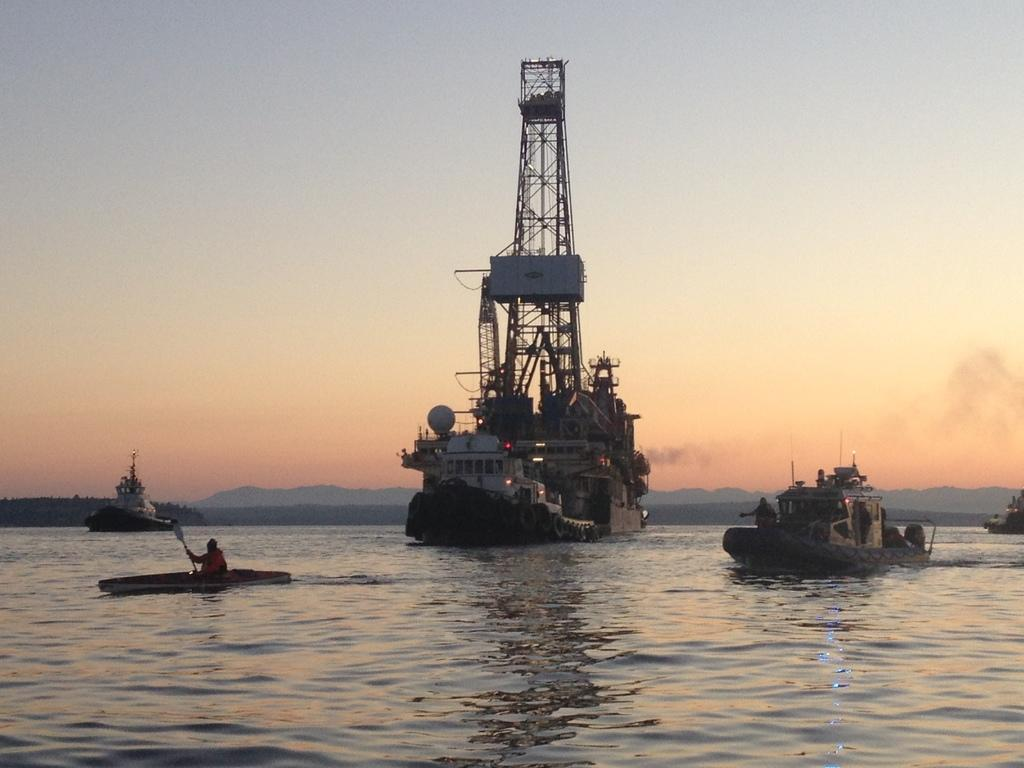What is the main subject of the image? The main subject of the image is a boat. Are there any other similar subjects in the image? Yes, there are ships in the image. What type of natural environment is visible in the image? There is water and hills visible in the image. What is visible in the sky in the image? The sky is visible in the image. What is the tendency of the porter in the image? There is no porter present in the image, so it is not possible to determine any tendencies. 